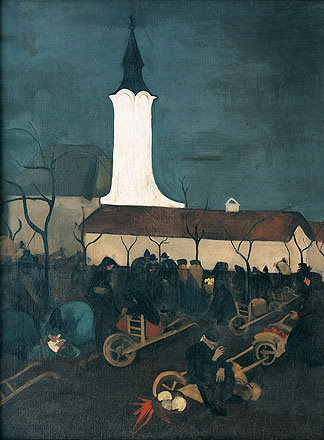Can you describe the atmosphere of the setting depicted in the image? The atmosphere in the image evokes a blend of tranquility and communal activity under a darkening sky. The gentle glow from the church steeple casts a serene light over the village, juxtaposing the busy figures who gather in preparation for a night event. The cool color palette used adds a somber yet peaceful mood, reflective of a collective endeavor in a rustic setting. 